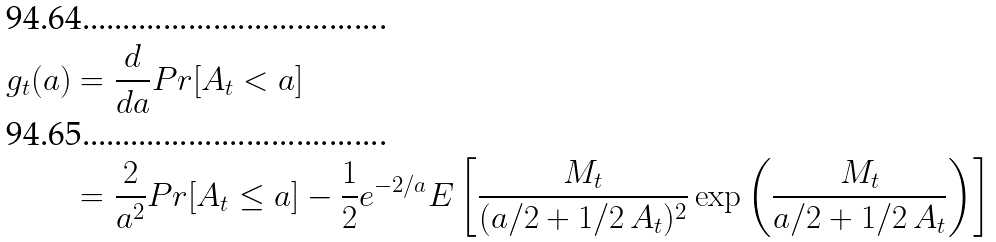Convert formula to latex. <formula><loc_0><loc_0><loc_500><loc_500>g _ { t } ( a ) & = \frac { d } { d a } P r [ A _ { t } < a ] \\ & = \frac { 2 } { a ^ { 2 } } P r [ A _ { t } \leq a ] - \frac { 1 } { 2 } e ^ { - 2 / a } E \left [ \frac { M _ { t } } { ( a / 2 + 1 / 2 \, A _ { t } ) ^ { 2 } } \exp \left ( \frac { M _ { t } } { a / 2 + 1 / 2 \, A _ { t } } \right ) \right ]</formula> 